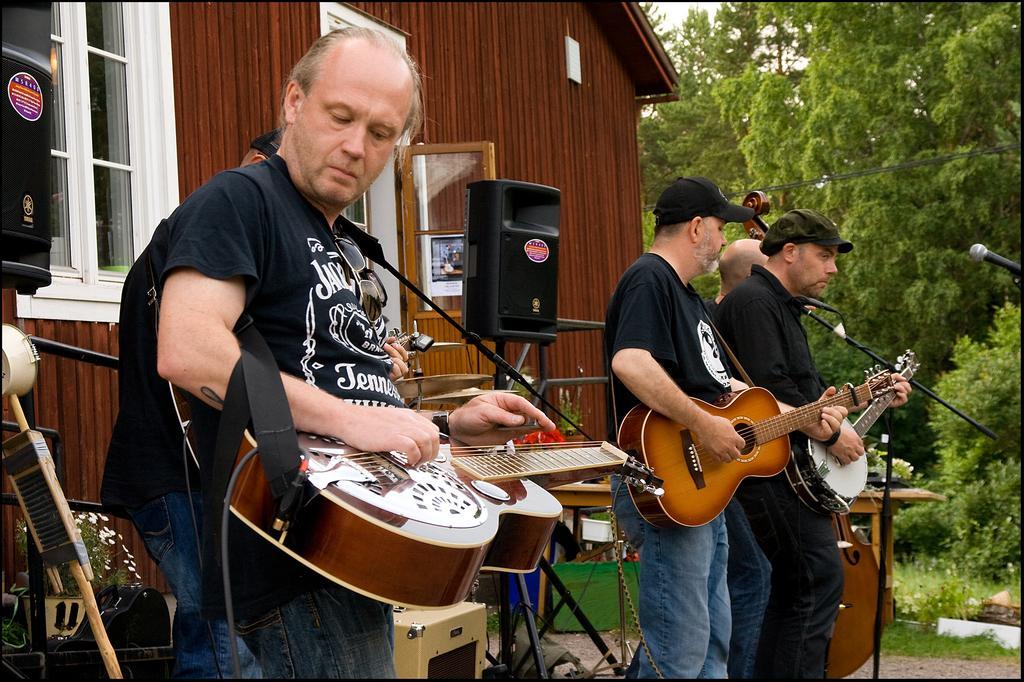Can you describe this image briefly? Persons are standing playing musical instrument. speaker,house,tree present in the back. 